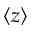Convert formula to latex. <formula><loc_0><loc_0><loc_500><loc_500>\langle z \rangle</formula> 